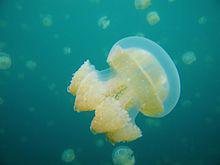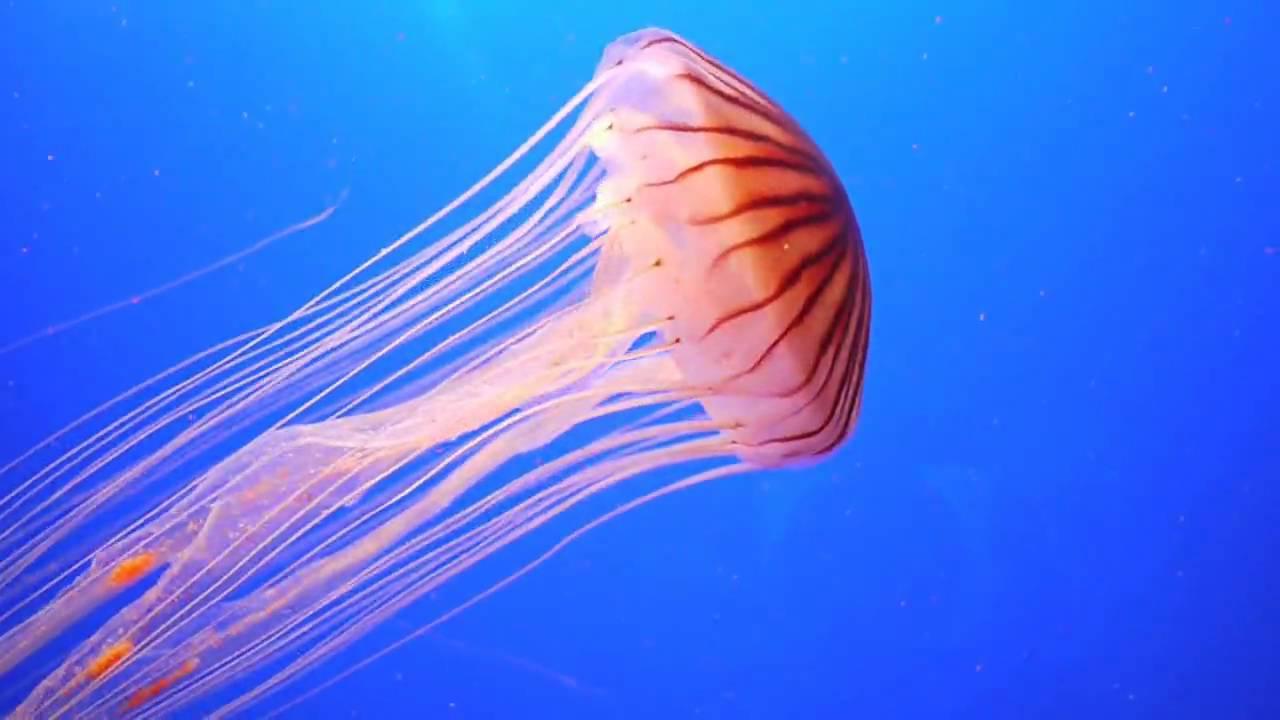The first image is the image on the left, the second image is the image on the right. For the images displayed, is the sentence "There are 3 jellyfish." factually correct? Answer yes or no. No. 